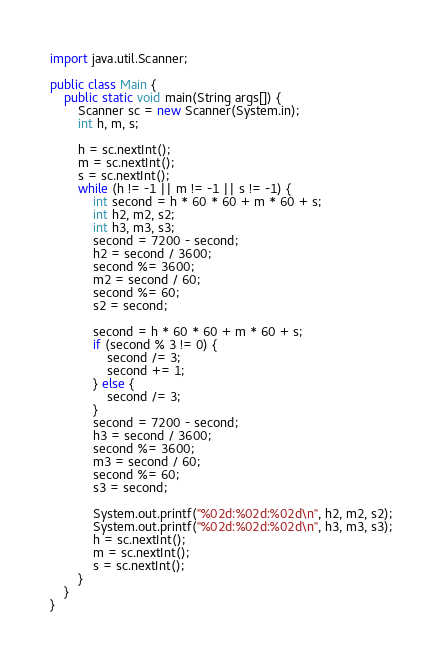Convert code to text. <code><loc_0><loc_0><loc_500><loc_500><_Java_>import java.util.Scanner;

public class Main {
	public static void main(String args[]) {
		Scanner sc = new Scanner(System.in);
		int h, m, s;

		h = sc.nextInt();
		m = sc.nextInt();
		s = sc.nextInt();
		while (h != -1 || m != -1 || s != -1) {
			int second = h * 60 * 60 + m * 60 + s;
			int h2, m2, s2;
			int h3, m3, s3;
			second = 7200 - second;
			h2 = second / 3600;
			second %= 3600;
			m2 = second / 60;
			second %= 60;
			s2 = second;

			second = h * 60 * 60 + m * 60 + s;
			if (second % 3 != 0) {
				second /= 3;
				second += 1;
			} else {
				second /= 3;
			}
			second = 7200 - second;
			h3 = second / 3600;
			second %= 3600;
			m3 = second / 60;
			second %= 60;
			s3 = second;

			System.out.printf("%02d:%02d:%02d\n", h2, m2, s2);
			System.out.printf("%02d:%02d:%02d\n", h3, m3, s3);
			h = sc.nextInt();
			m = sc.nextInt();
			s = sc.nextInt();
		}
	}
}</code> 